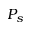<formula> <loc_0><loc_0><loc_500><loc_500>P _ { s }</formula> 